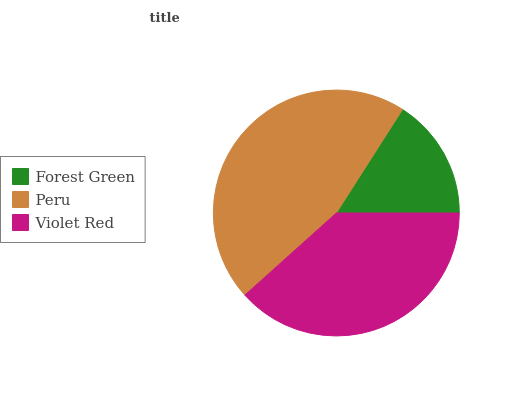Is Forest Green the minimum?
Answer yes or no. Yes. Is Peru the maximum?
Answer yes or no. Yes. Is Violet Red the minimum?
Answer yes or no. No. Is Violet Red the maximum?
Answer yes or no. No. Is Peru greater than Violet Red?
Answer yes or no. Yes. Is Violet Red less than Peru?
Answer yes or no. Yes. Is Violet Red greater than Peru?
Answer yes or no. No. Is Peru less than Violet Red?
Answer yes or no. No. Is Violet Red the high median?
Answer yes or no. Yes. Is Violet Red the low median?
Answer yes or no. Yes. Is Forest Green the high median?
Answer yes or no. No. Is Peru the low median?
Answer yes or no. No. 